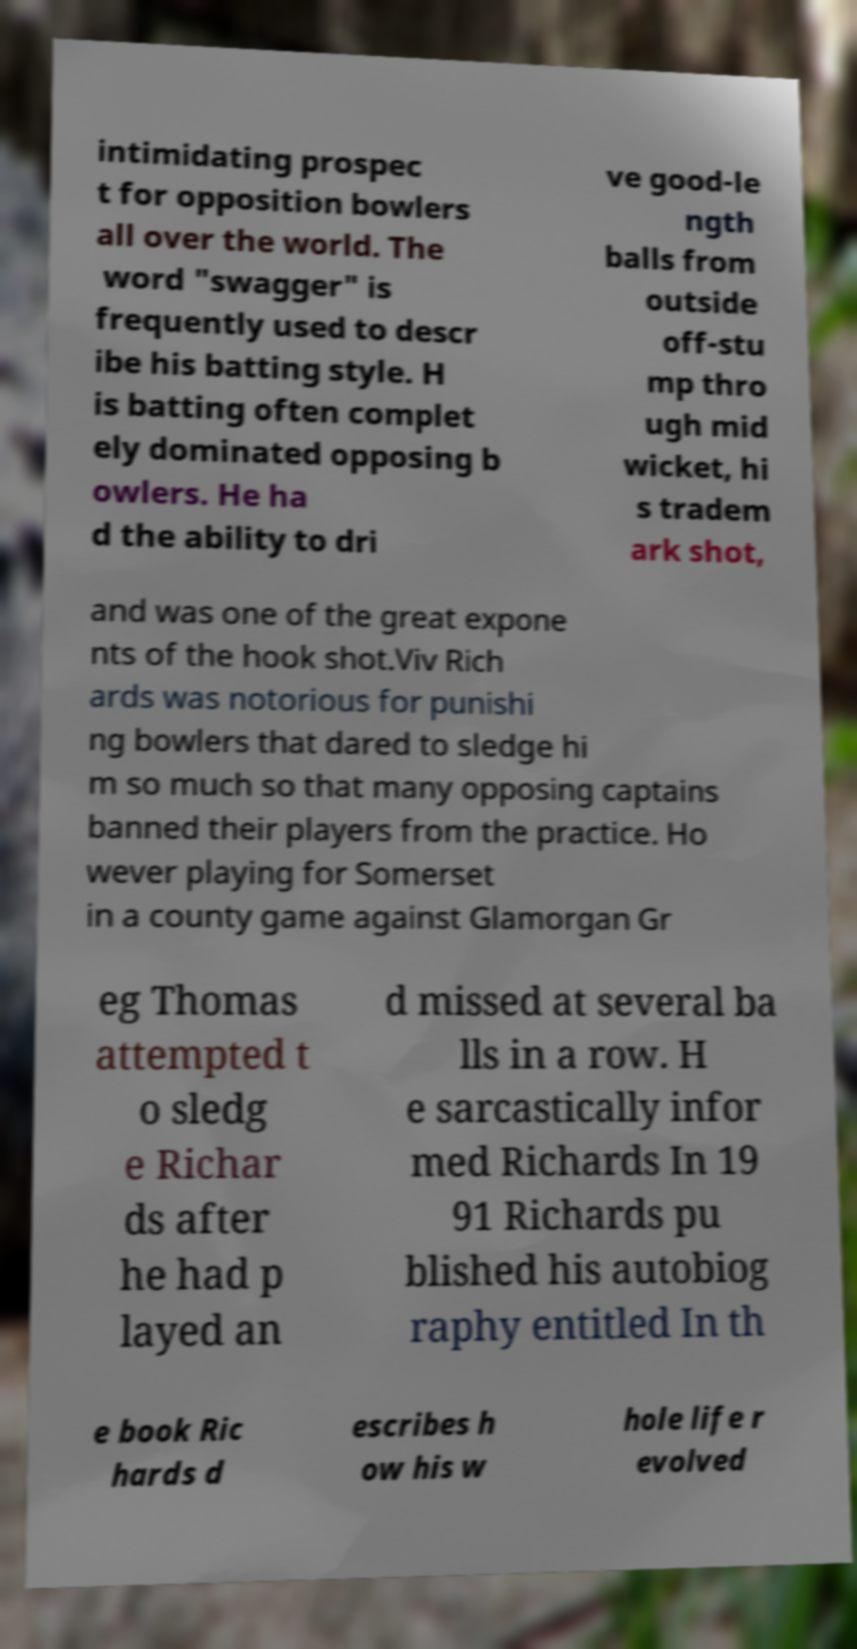Can you read and provide the text displayed in the image?This photo seems to have some interesting text. Can you extract and type it out for me? intimidating prospec t for opposition bowlers all over the world. The word "swagger" is frequently used to descr ibe his batting style. H is batting often complet ely dominated opposing b owlers. He ha d the ability to dri ve good-le ngth balls from outside off-stu mp thro ugh mid wicket, hi s tradem ark shot, and was one of the great expone nts of the hook shot.Viv Rich ards was notorious for punishi ng bowlers that dared to sledge hi m so much so that many opposing captains banned their players from the practice. Ho wever playing for Somerset in a county game against Glamorgan Gr eg Thomas attempted t o sledg e Richar ds after he had p layed an d missed at several ba lls in a row. H e sarcastically infor med Richards In 19 91 Richards pu blished his autobiog raphy entitled In th e book Ric hards d escribes h ow his w hole life r evolved 